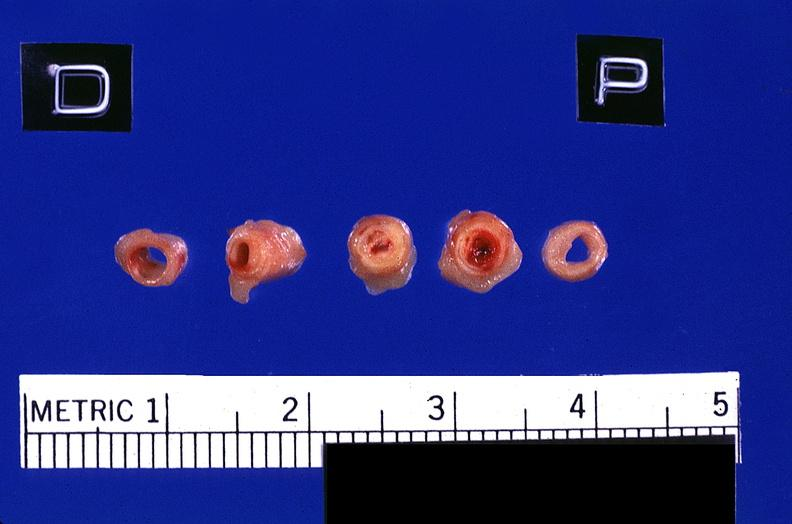s notochord present?
Answer the question using a single word or phrase. No 